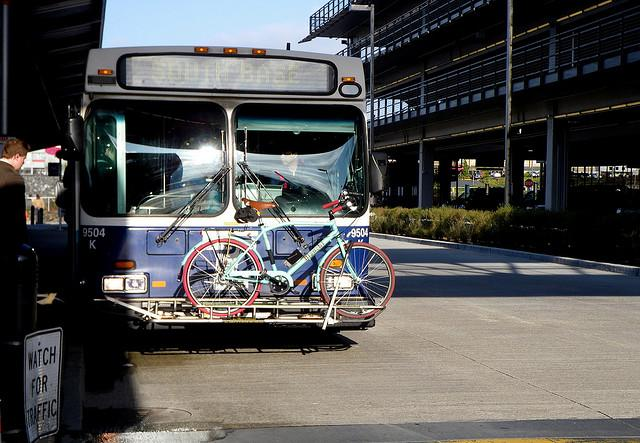Where is the rider of the bike? inside bus 